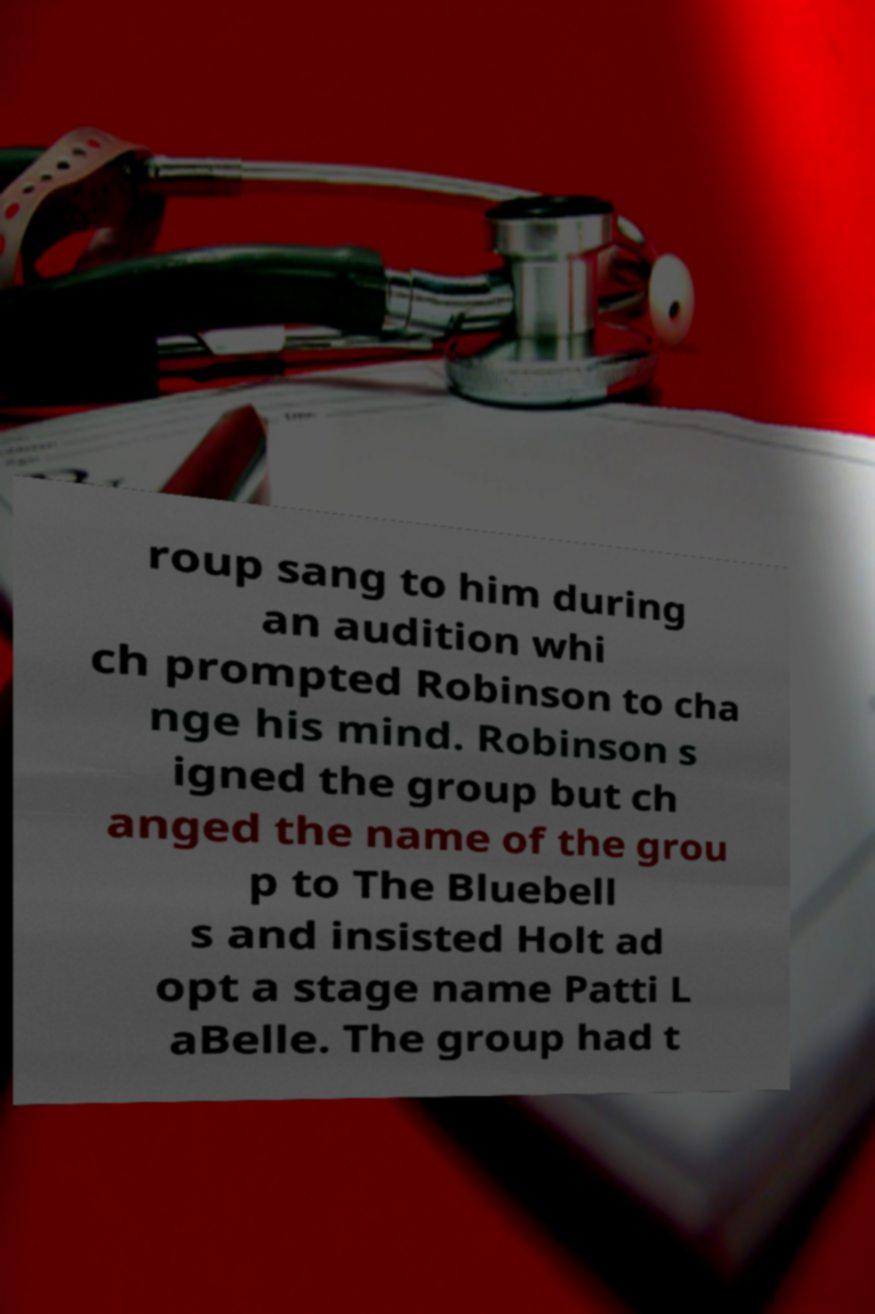I need the written content from this picture converted into text. Can you do that? roup sang to him during an audition whi ch prompted Robinson to cha nge his mind. Robinson s igned the group but ch anged the name of the grou p to The Bluebell s and insisted Holt ad opt a stage name Patti L aBelle. The group had t 